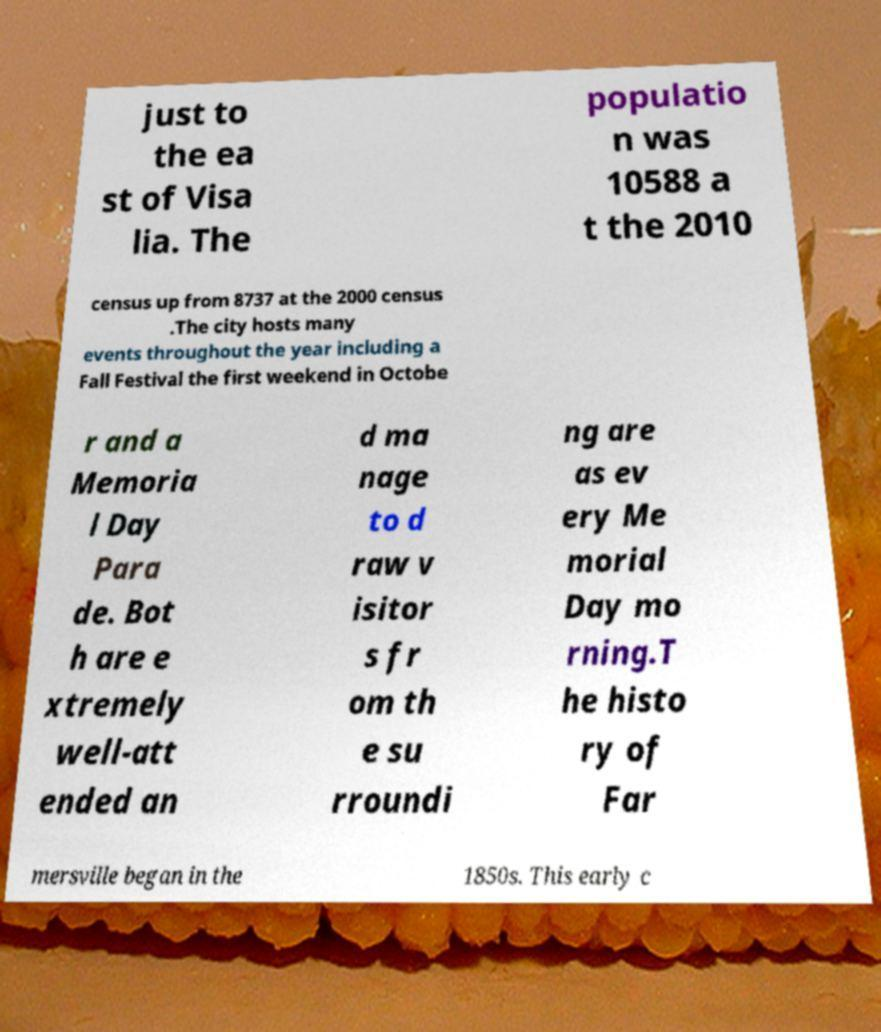Please identify and transcribe the text found in this image. just to the ea st of Visa lia. The populatio n was 10588 a t the 2010 census up from 8737 at the 2000 census .The city hosts many events throughout the year including a Fall Festival the first weekend in Octobe r and a Memoria l Day Para de. Bot h are e xtremely well-att ended an d ma nage to d raw v isitor s fr om th e su rroundi ng are as ev ery Me morial Day mo rning.T he histo ry of Far mersville began in the 1850s. This early c 